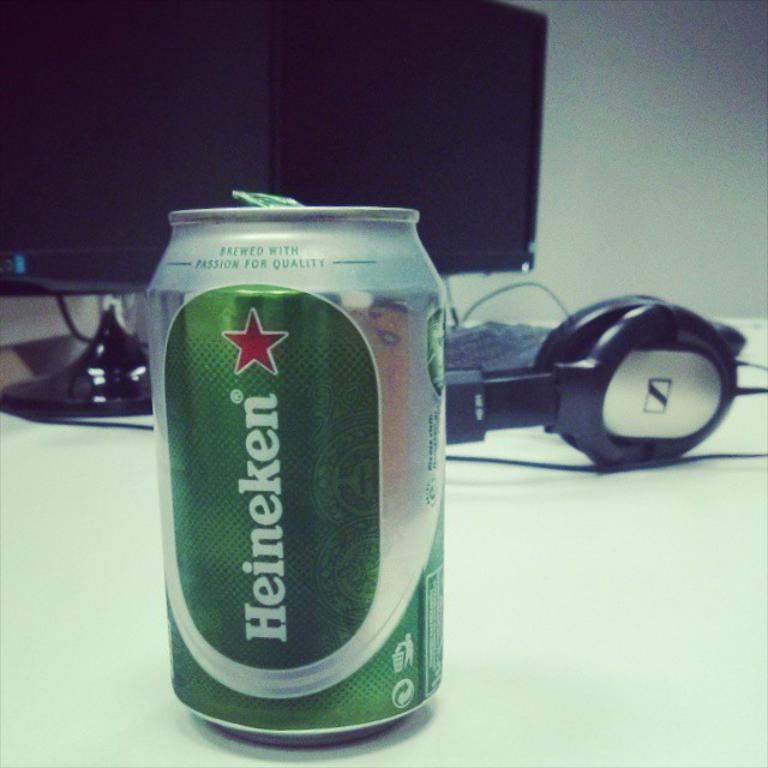Provide a one-sentence caption for the provided image. A can of Heineken beer sitting on a desk in front of a computer monitor. 